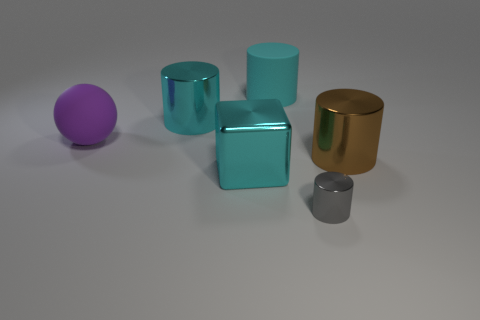Is there any other thing that has the same size as the gray thing?
Your answer should be very brief. No. Is there any other thing that is the same shape as the purple object?
Ensure brevity in your answer.  No. Does the big metallic block have the same color as the big object on the right side of the small gray metal cylinder?
Ensure brevity in your answer.  No. What number of big cylinders are the same color as the big matte ball?
Provide a succinct answer. 0. What size is the purple ball in front of the big cyan cylinder that is in front of the large cyan matte thing?
Offer a very short reply. Large. What number of objects are either big shiny objects that are left of the gray object or big brown metallic cubes?
Your response must be concise. 2. Are there any other balls that have the same size as the matte sphere?
Offer a very short reply. No. There is a metal cylinder to the right of the gray metal object; is there a large metallic cylinder that is on the left side of it?
Your answer should be compact. Yes. What number of cubes are large purple things or gray shiny things?
Offer a very short reply. 0. Is there a blue metallic object that has the same shape as the purple thing?
Your answer should be very brief. No. 